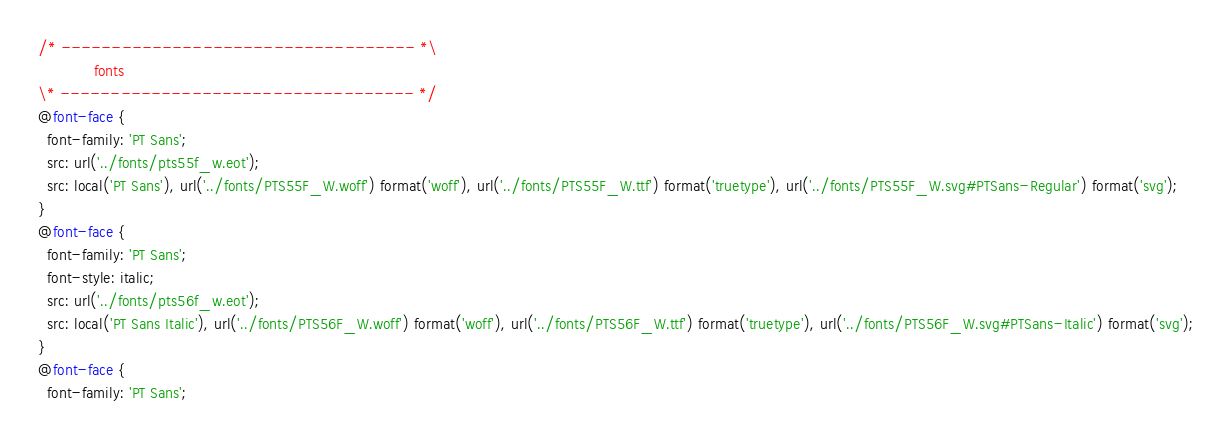<code> <loc_0><loc_0><loc_500><loc_500><_CSS_>/* ----------------------------------- *\
			fonts
\* ----------------------------------- */
@font-face {
  font-family: 'PT Sans';
  src: url('../fonts/pts55f_w.eot');
  src: local('PT Sans'), url('../fonts/PTS55F_W.woff') format('woff'), url('../fonts/PTS55F_W.ttf') format('truetype'), url('../fonts/PTS55F_W.svg#PTSans-Regular') format('svg');
}
@font-face {
  font-family: 'PT Sans';
  font-style: italic;
  src: url('../fonts/pts56f_w.eot');
  src: local('PT Sans Italic'), url('../fonts/PTS56F_W.woff') format('woff'), url('../fonts/PTS56F_W.ttf') format('truetype'), url('../fonts/PTS56F_W.svg#PTSans-Italic') format('svg');
}
@font-face {
  font-family: 'PT Sans';</code> 